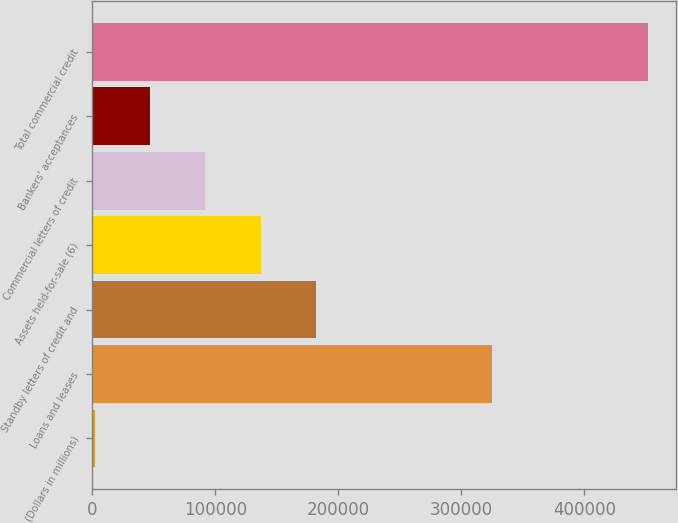Convert chart to OTSL. <chart><loc_0><loc_0><loc_500><loc_500><bar_chart><fcel>(Dollars in millions)<fcel>Loans and leases<fcel>Standby letters of credit and<fcel>Assets held-for-sale (6)<fcel>Commercial letters of credit<fcel>Bankers' acceptances<fcel>Total commercial credit<nl><fcel>2007<fcel>325143<fcel>181975<fcel>136983<fcel>91990.8<fcel>46998.9<fcel>451926<nl></chart> 